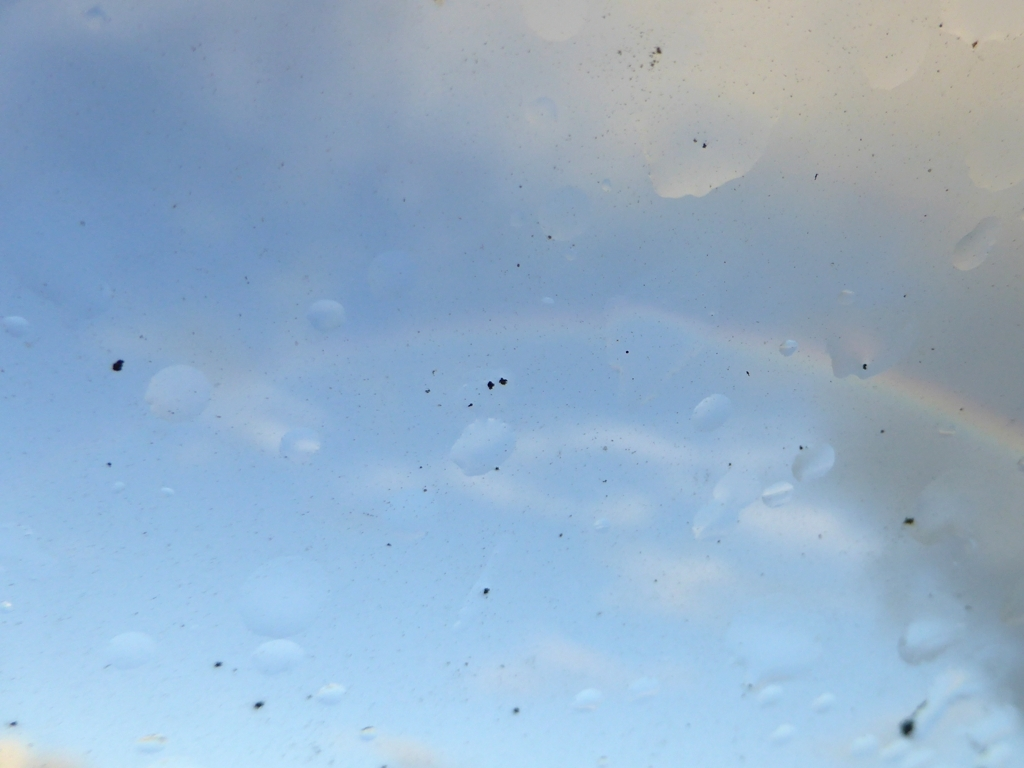How would you describe the overall clarity of the image? The clarity of the image is below average; it appears to be quite blurry, with potential smudges or condensation on the lens. There's also a faint rainbow which suggests the presence of sunlight and moisture. 